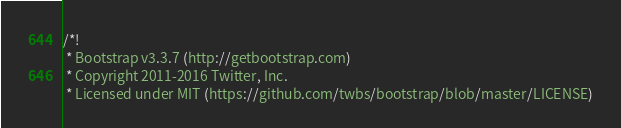Convert code to text. <code><loc_0><loc_0><loc_500><loc_500><_CSS_>/*!
 * Bootstrap v3.3.7 (http://getbootstrap.com)
 * Copyright 2011-2016 Twitter, Inc.
 * Licensed under MIT (https://github.com/twbs/bootstrap/blob/master/LICENSE)</code> 